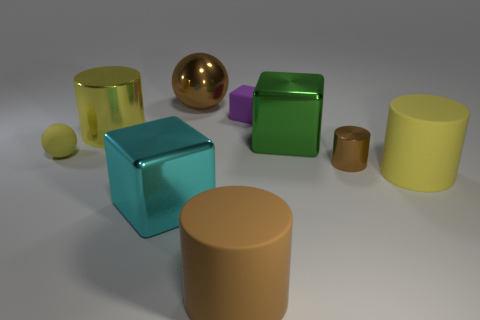Subtract all cyan cylinders. Subtract all cyan spheres. How many cylinders are left? 4 Subtract all spheres. How many objects are left? 7 Add 9 purple matte blocks. How many purple matte blocks exist? 10 Subtract 0 green cylinders. How many objects are left? 9 Subtract all big yellow rubber cylinders. Subtract all small purple rubber things. How many objects are left? 7 Add 2 cyan blocks. How many cyan blocks are left? 3 